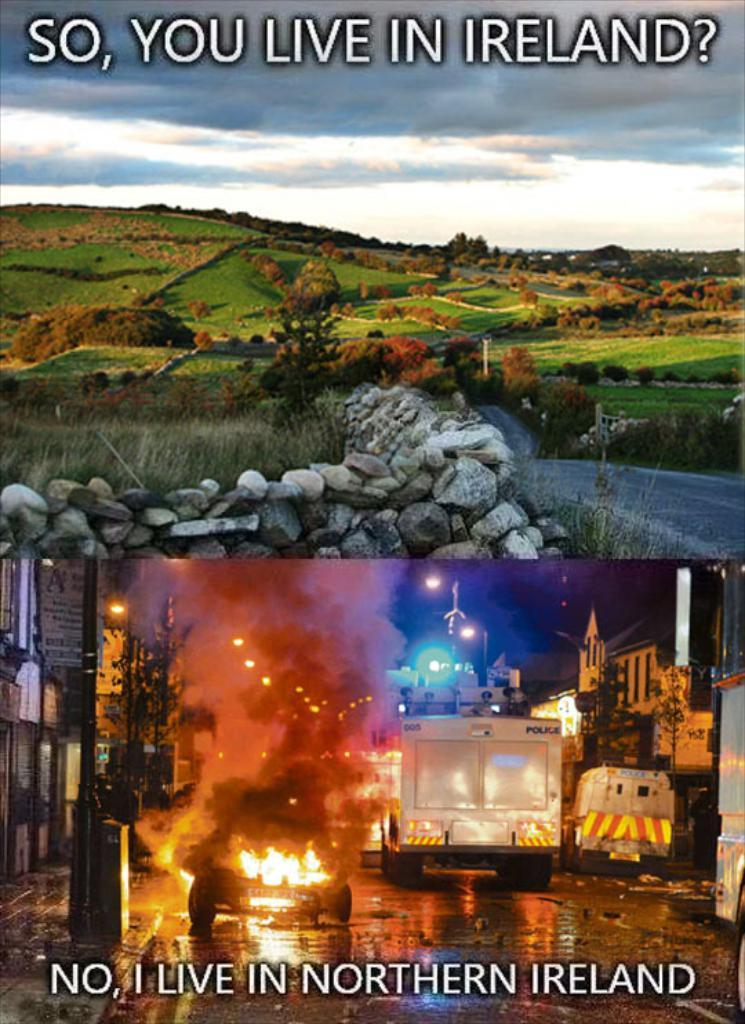What type of natural environment is visible in the image? There is grass and mountains in the image, indicating a natural environment. What other elements can be seen in the image? There is greenery, vehicles on the road, and fire in the image. What type of soda is being distributed in the image? There is no soda present in the image. Can you see any blood in the image? There is no blood visible in the image. 